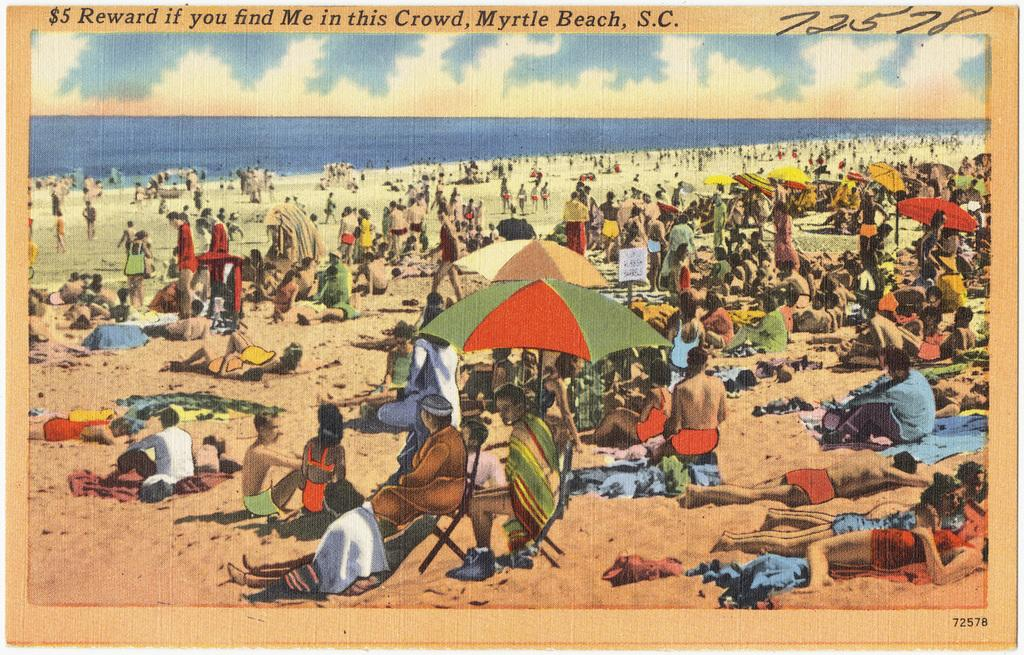<image>
Summarize the visual content of the image. Postcard showing a beach scene from Mytle Beach, S.C. 